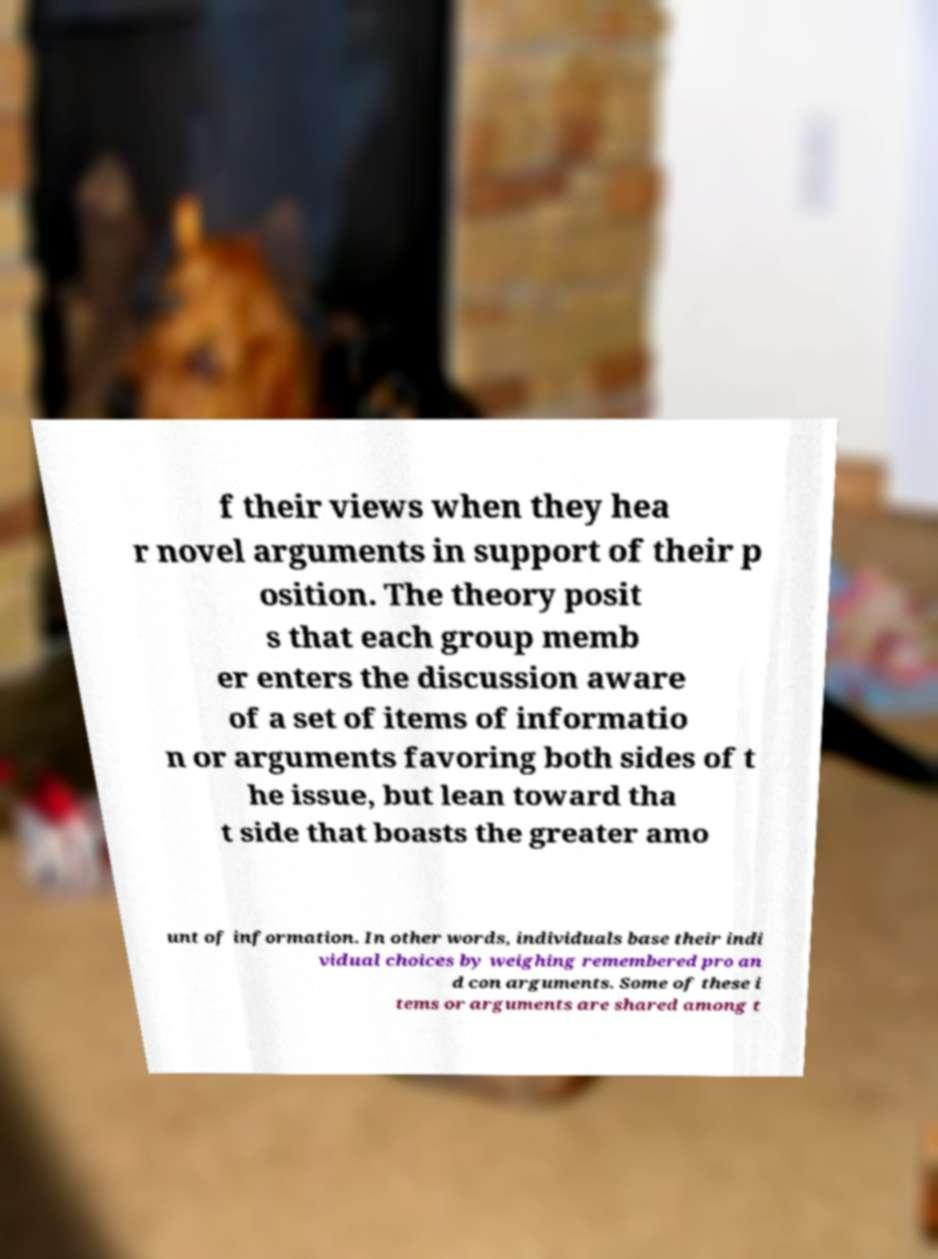What messages or text are displayed in this image? I need them in a readable, typed format. f their views when they hea r novel arguments in support of their p osition. The theory posit s that each group memb er enters the discussion aware of a set of items of informatio n or arguments favoring both sides of t he issue, but lean toward tha t side that boasts the greater amo unt of information. In other words, individuals base their indi vidual choices by weighing remembered pro an d con arguments. Some of these i tems or arguments are shared among t 